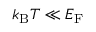Convert formula to latex. <formula><loc_0><loc_0><loc_500><loc_500>k _ { B } T \ll E _ { F }</formula> 